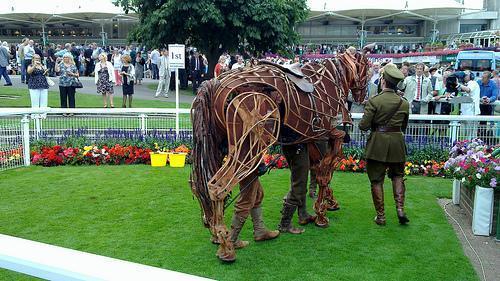How many people are in the horse costume?
Give a very brief answer. 2. 